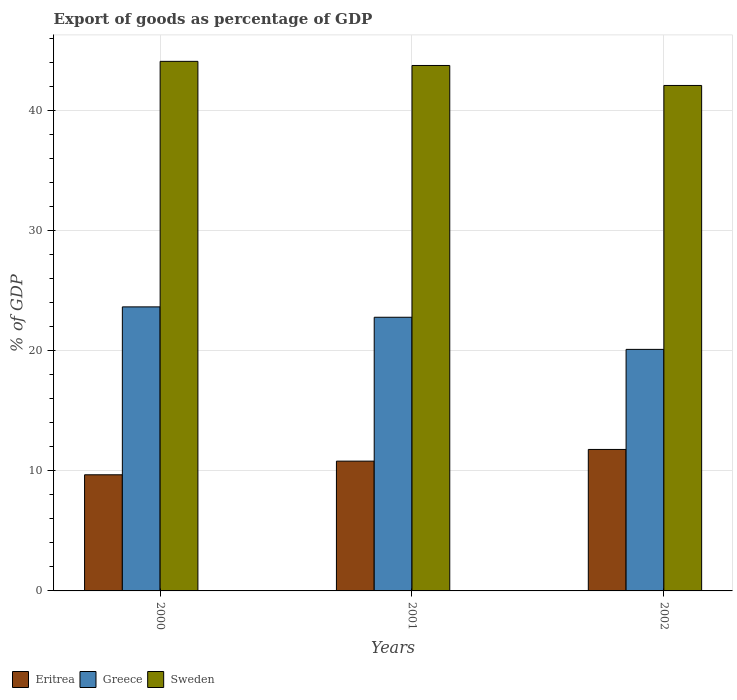How many different coloured bars are there?
Offer a terse response. 3. How many groups of bars are there?
Offer a very short reply. 3. How many bars are there on the 1st tick from the right?
Give a very brief answer. 3. What is the label of the 1st group of bars from the left?
Your response must be concise. 2000. What is the export of goods as percentage of GDP in Sweden in 2002?
Provide a short and direct response. 42.09. Across all years, what is the maximum export of goods as percentage of GDP in Sweden?
Keep it short and to the point. 44.1. Across all years, what is the minimum export of goods as percentage of GDP in Greece?
Provide a short and direct response. 20.11. In which year was the export of goods as percentage of GDP in Greece minimum?
Keep it short and to the point. 2002. What is the total export of goods as percentage of GDP in Greece in the graph?
Your response must be concise. 66.55. What is the difference between the export of goods as percentage of GDP in Sweden in 2000 and that in 2002?
Provide a short and direct response. 2.01. What is the difference between the export of goods as percentage of GDP in Greece in 2000 and the export of goods as percentage of GDP in Eritrea in 2002?
Ensure brevity in your answer.  11.87. What is the average export of goods as percentage of GDP in Greece per year?
Provide a succinct answer. 22.18. In the year 2002, what is the difference between the export of goods as percentage of GDP in Sweden and export of goods as percentage of GDP in Eritrea?
Ensure brevity in your answer.  30.31. In how many years, is the export of goods as percentage of GDP in Sweden greater than 10 %?
Keep it short and to the point. 3. What is the ratio of the export of goods as percentage of GDP in Eritrea in 2001 to that in 2002?
Provide a succinct answer. 0.92. Is the export of goods as percentage of GDP in Sweden in 2001 less than that in 2002?
Provide a short and direct response. No. Is the difference between the export of goods as percentage of GDP in Sweden in 2000 and 2001 greater than the difference between the export of goods as percentage of GDP in Eritrea in 2000 and 2001?
Your answer should be very brief. Yes. What is the difference between the highest and the second highest export of goods as percentage of GDP in Sweden?
Give a very brief answer. 0.34. What is the difference between the highest and the lowest export of goods as percentage of GDP in Sweden?
Your response must be concise. 2.01. In how many years, is the export of goods as percentage of GDP in Greece greater than the average export of goods as percentage of GDP in Greece taken over all years?
Your answer should be compact. 2. What does the 3rd bar from the left in 2002 represents?
Offer a terse response. Sweden. What does the 3rd bar from the right in 2002 represents?
Ensure brevity in your answer.  Eritrea. How many bars are there?
Your response must be concise. 9. What is the difference between two consecutive major ticks on the Y-axis?
Your answer should be compact. 10. Does the graph contain any zero values?
Provide a short and direct response. No. How are the legend labels stacked?
Provide a short and direct response. Horizontal. What is the title of the graph?
Your response must be concise. Export of goods as percentage of GDP. What is the label or title of the Y-axis?
Your answer should be very brief. % of GDP. What is the % of GDP in Eritrea in 2000?
Provide a short and direct response. 9.67. What is the % of GDP of Greece in 2000?
Your answer should be compact. 23.65. What is the % of GDP of Sweden in 2000?
Your response must be concise. 44.1. What is the % of GDP of Eritrea in 2001?
Offer a terse response. 10.81. What is the % of GDP in Greece in 2001?
Ensure brevity in your answer.  22.79. What is the % of GDP in Sweden in 2001?
Your answer should be compact. 43.75. What is the % of GDP of Eritrea in 2002?
Make the answer very short. 11.78. What is the % of GDP in Greece in 2002?
Your answer should be compact. 20.11. What is the % of GDP in Sweden in 2002?
Provide a succinct answer. 42.09. Across all years, what is the maximum % of GDP of Eritrea?
Your answer should be very brief. 11.78. Across all years, what is the maximum % of GDP in Greece?
Provide a short and direct response. 23.65. Across all years, what is the maximum % of GDP of Sweden?
Offer a terse response. 44.1. Across all years, what is the minimum % of GDP of Eritrea?
Provide a succinct answer. 9.67. Across all years, what is the minimum % of GDP of Greece?
Provide a succinct answer. 20.11. Across all years, what is the minimum % of GDP of Sweden?
Your answer should be very brief. 42.09. What is the total % of GDP of Eritrea in the graph?
Your answer should be compact. 32.26. What is the total % of GDP in Greece in the graph?
Offer a very short reply. 66.55. What is the total % of GDP of Sweden in the graph?
Offer a very short reply. 129.94. What is the difference between the % of GDP in Eritrea in 2000 and that in 2001?
Keep it short and to the point. -1.14. What is the difference between the % of GDP of Greece in 2000 and that in 2001?
Make the answer very short. 0.86. What is the difference between the % of GDP in Sweden in 2000 and that in 2001?
Give a very brief answer. 0.34. What is the difference between the % of GDP in Eritrea in 2000 and that in 2002?
Your answer should be very brief. -2.11. What is the difference between the % of GDP in Greece in 2000 and that in 2002?
Provide a succinct answer. 3.54. What is the difference between the % of GDP in Sweden in 2000 and that in 2002?
Offer a very short reply. 2.01. What is the difference between the % of GDP in Eritrea in 2001 and that in 2002?
Make the answer very short. -0.97. What is the difference between the % of GDP of Greece in 2001 and that in 2002?
Provide a succinct answer. 2.68. What is the difference between the % of GDP in Sweden in 2001 and that in 2002?
Offer a terse response. 1.66. What is the difference between the % of GDP in Eritrea in 2000 and the % of GDP in Greece in 2001?
Offer a terse response. -13.12. What is the difference between the % of GDP of Eritrea in 2000 and the % of GDP of Sweden in 2001?
Provide a short and direct response. -34.08. What is the difference between the % of GDP in Greece in 2000 and the % of GDP in Sweden in 2001?
Offer a very short reply. -20.1. What is the difference between the % of GDP of Eritrea in 2000 and the % of GDP of Greece in 2002?
Ensure brevity in your answer.  -10.44. What is the difference between the % of GDP of Eritrea in 2000 and the % of GDP of Sweden in 2002?
Your answer should be very brief. -32.42. What is the difference between the % of GDP in Greece in 2000 and the % of GDP in Sweden in 2002?
Keep it short and to the point. -18.44. What is the difference between the % of GDP of Eritrea in 2001 and the % of GDP of Greece in 2002?
Make the answer very short. -9.31. What is the difference between the % of GDP of Eritrea in 2001 and the % of GDP of Sweden in 2002?
Provide a short and direct response. -31.28. What is the difference between the % of GDP of Greece in 2001 and the % of GDP of Sweden in 2002?
Your response must be concise. -19.3. What is the average % of GDP of Eritrea per year?
Provide a succinct answer. 10.75. What is the average % of GDP of Greece per year?
Your answer should be very brief. 22.18. What is the average % of GDP in Sweden per year?
Offer a terse response. 43.31. In the year 2000, what is the difference between the % of GDP of Eritrea and % of GDP of Greece?
Make the answer very short. -13.98. In the year 2000, what is the difference between the % of GDP of Eritrea and % of GDP of Sweden?
Keep it short and to the point. -34.43. In the year 2000, what is the difference between the % of GDP of Greece and % of GDP of Sweden?
Provide a short and direct response. -20.45. In the year 2001, what is the difference between the % of GDP of Eritrea and % of GDP of Greece?
Your response must be concise. -11.98. In the year 2001, what is the difference between the % of GDP in Eritrea and % of GDP in Sweden?
Keep it short and to the point. -32.95. In the year 2001, what is the difference between the % of GDP of Greece and % of GDP of Sweden?
Provide a succinct answer. -20.97. In the year 2002, what is the difference between the % of GDP of Eritrea and % of GDP of Greece?
Your response must be concise. -8.33. In the year 2002, what is the difference between the % of GDP of Eritrea and % of GDP of Sweden?
Offer a terse response. -30.31. In the year 2002, what is the difference between the % of GDP of Greece and % of GDP of Sweden?
Keep it short and to the point. -21.98. What is the ratio of the % of GDP in Eritrea in 2000 to that in 2001?
Make the answer very short. 0.89. What is the ratio of the % of GDP in Greece in 2000 to that in 2001?
Provide a succinct answer. 1.04. What is the ratio of the % of GDP in Sweden in 2000 to that in 2001?
Provide a short and direct response. 1.01. What is the ratio of the % of GDP of Eritrea in 2000 to that in 2002?
Provide a succinct answer. 0.82. What is the ratio of the % of GDP in Greece in 2000 to that in 2002?
Keep it short and to the point. 1.18. What is the ratio of the % of GDP of Sweden in 2000 to that in 2002?
Your answer should be compact. 1.05. What is the ratio of the % of GDP of Eritrea in 2001 to that in 2002?
Offer a very short reply. 0.92. What is the ratio of the % of GDP in Greece in 2001 to that in 2002?
Keep it short and to the point. 1.13. What is the ratio of the % of GDP of Sweden in 2001 to that in 2002?
Ensure brevity in your answer.  1.04. What is the difference between the highest and the second highest % of GDP in Eritrea?
Your response must be concise. 0.97. What is the difference between the highest and the second highest % of GDP in Greece?
Your answer should be compact. 0.86. What is the difference between the highest and the second highest % of GDP in Sweden?
Make the answer very short. 0.34. What is the difference between the highest and the lowest % of GDP in Eritrea?
Offer a terse response. 2.11. What is the difference between the highest and the lowest % of GDP in Greece?
Make the answer very short. 3.54. What is the difference between the highest and the lowest % of GDP in Sweden?
Make the answer very short. 2.01. 